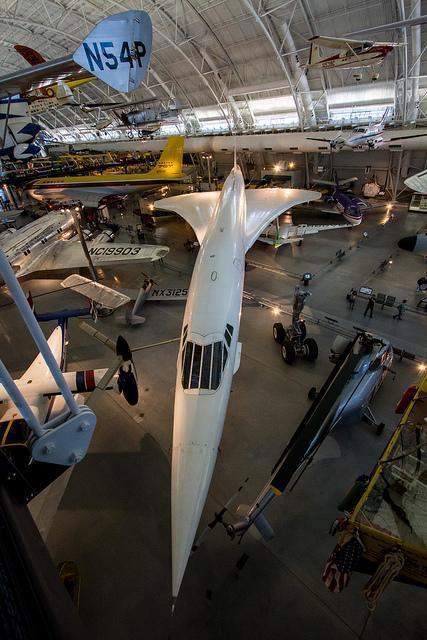How many airplanes can you see?
Give a very brief answer. 6. 